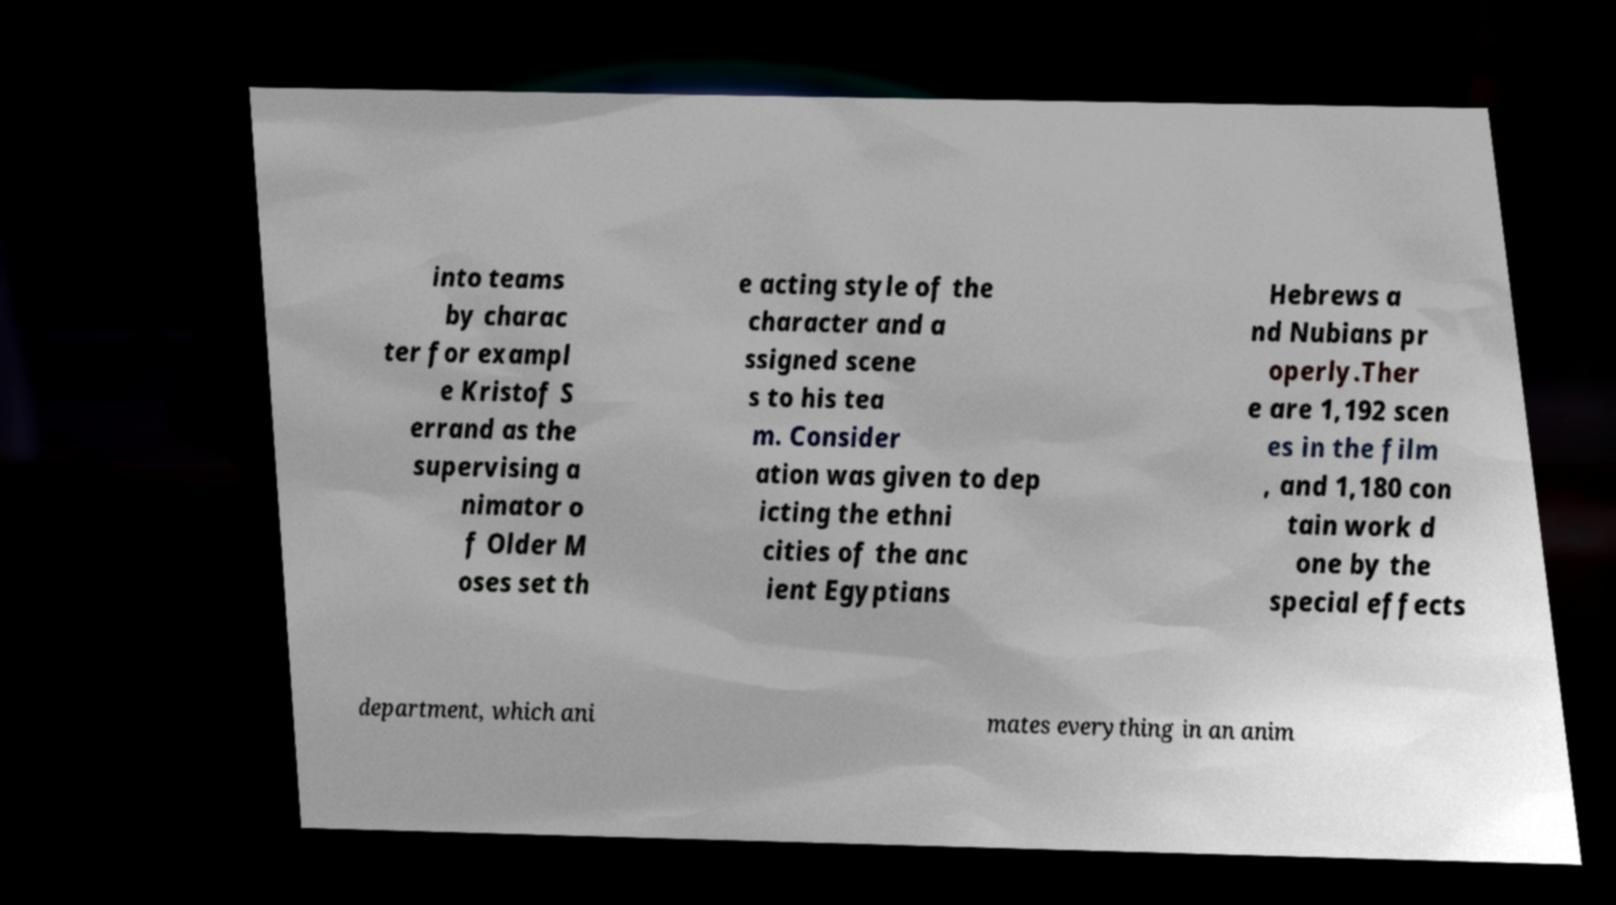Please read and relay the text visible in this image. What does it say? into teams by charac ter for exampl e Kristof S errand as the supervising a nimator o f Older M oses set th e acting style of the character and a ssigned scene s to his tea m. Consider ation was given to dep icting the ethni cities of the anc ient Egyptians Hebrews a nd Nubians pr operly.Ther e are 1,192 scen es in the film , and 1,180 con tain work d one by the special effects department, which ani mates everything in an anim 